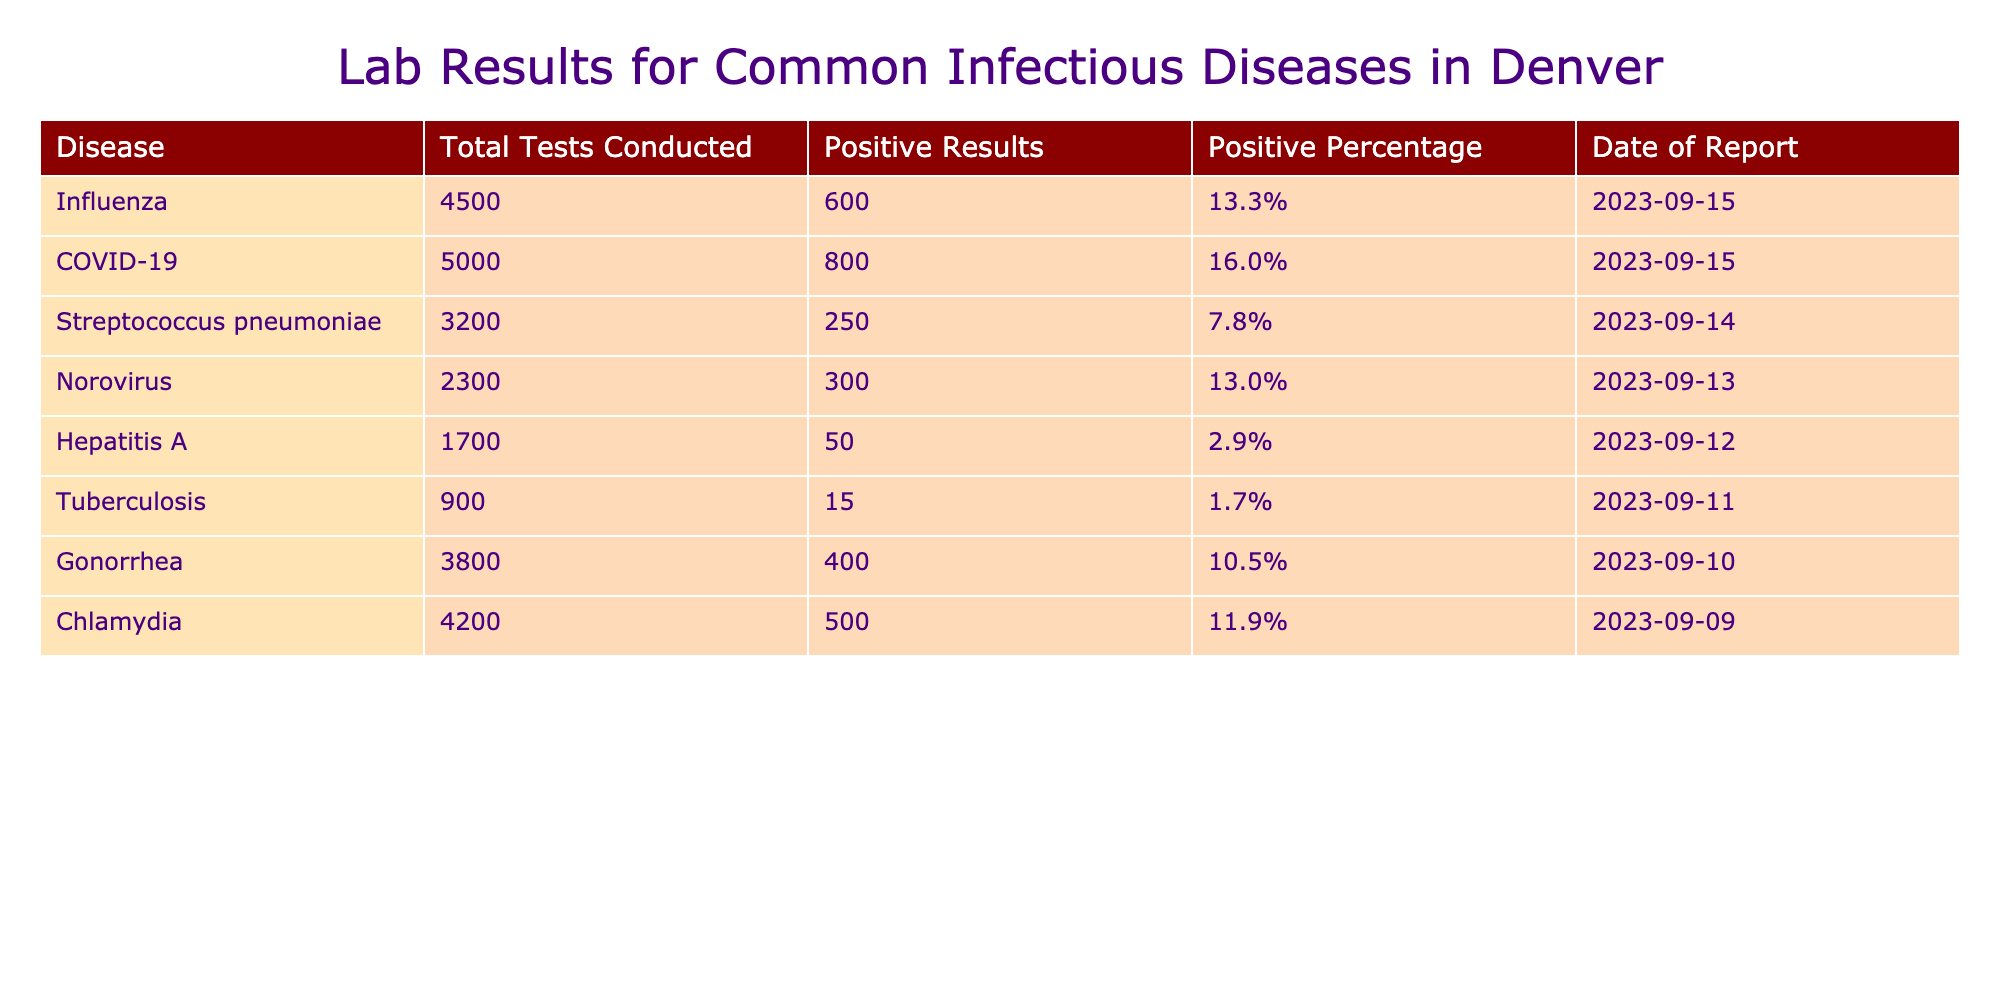What is the disease with the highest positive percentage? Looking at the table, COVID-19 has the highest positive percentage at 16.0%. This is determined by comparing the "Positive Percentage" values for all listed diseases.
Answer: COVID-19 How many total tests were conducted for influenza? The "Total Tests Conducted" column shows that 4500 tests were conducted for influenza. This value can be directly found in the corresponding row.
Answer: 4500 What is the positive result count for Norovirus? Referring to the table, Norovirus has 300 positive results, which can be identified in the "Positive Results" column for that disease.
Answer: 300 Is the positive percentage for Hepatitis A greater than 5%? By checking the "Positive Percentage" for Hepatitis A, which is 2.9%, it is evident that it is less than 5%. Therefore, the answer is no.
Answer: No What is the total number of positive results for Chlamydia and Gonorrhea combined? For Chlamydia, the positive results are 500 and for Gonorrhea, they are 400. Adding these two figures (500 + 400) gives a total of 900 positive results for both diseases combined.
Answer: 900 Does Tuberculosis have a higher positive result than Streptococcus pneumoniae? Tuberculosis has 15 positive results, while Streptococcus pneumoniae has 250 positive results. Since 15 is less than 250, Tuberculosis does not have a higher positive result. Therefore, the answer is no.
Answer: No What percentage of tests conducted for Streptococcus pneumoniae tested positive? The table indicates that for Streptococcus pneumoniae, 250 tests were positive out of 3200 conducted. To find the percentage, calculate (250 / 3200) * 100, which equals approximately 7.8%. This is explicitly stated in the "Positive Percentage" column.
Answer: 7.8% What is the difference in total tests conducted between COVID-19 and Tuberculosis? COVID-19 has 5000 total tests conducted, whereas Tuberculosis has 900. To find the difference, subtract the two values: 5000 - 900 = 4100.
Answer: 4100 What is the average positive percentage of Chlamydia and Gonorrhea? Chlamydia has a positive percentage of 11.9% and Gonorrhea has 10.5%. To find the average, add these rates (11.9 + 10.5) and then divide by 2: (22.4 / 2) = 11.2%.
Answer: 11.2 